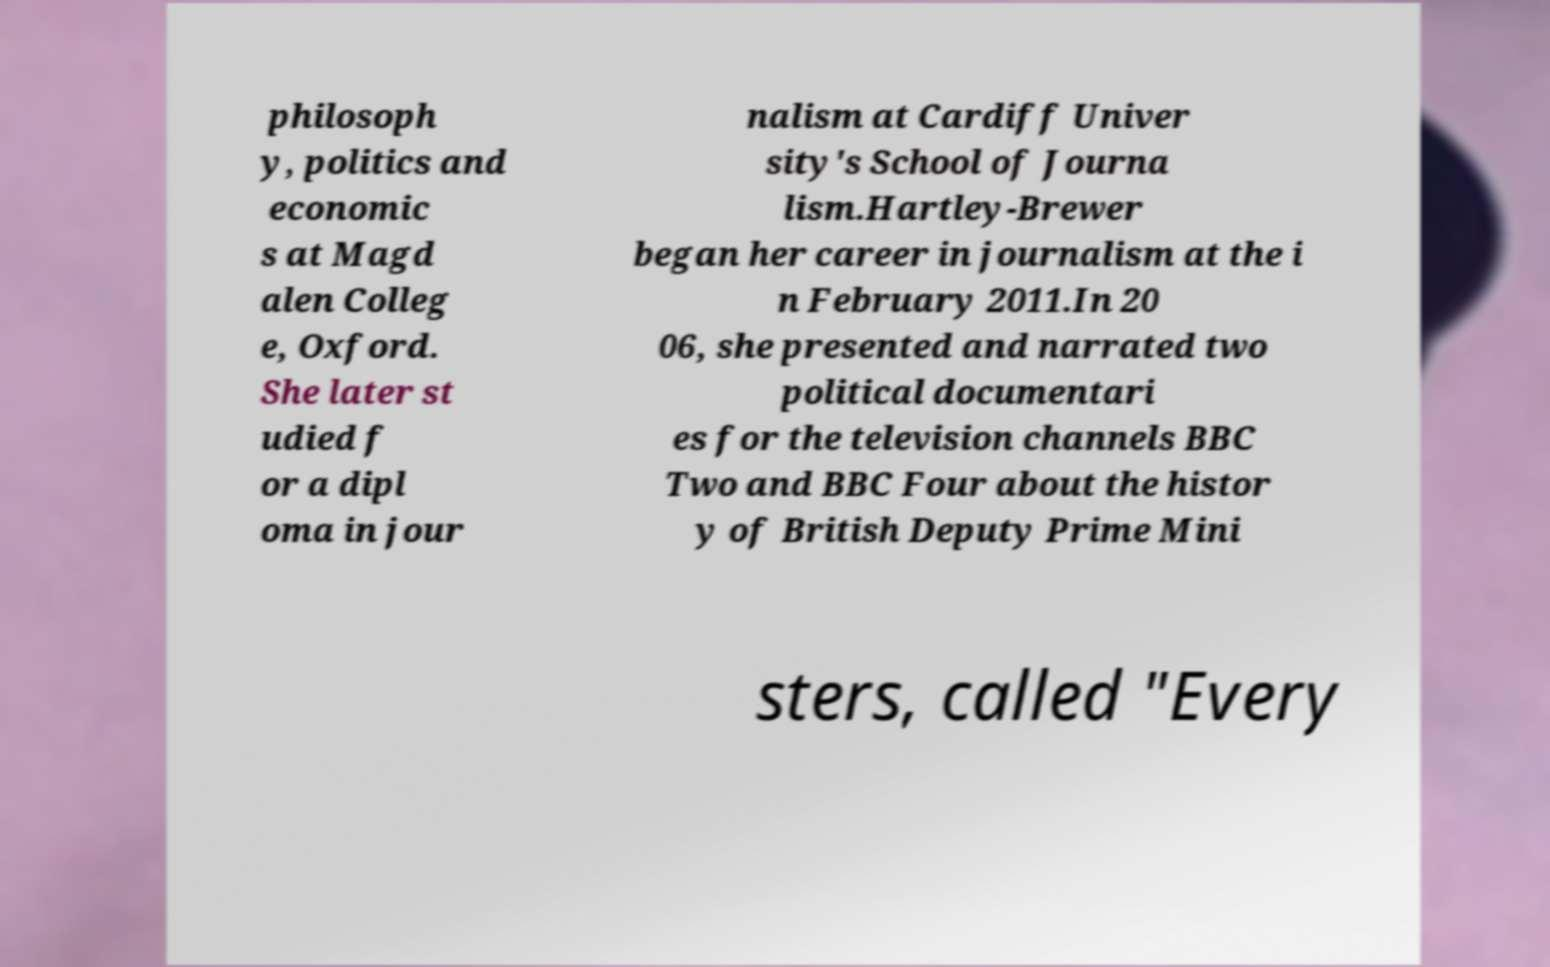I need the written content from this picture converted into text. Can you do that? philosoph y, politics and economic s at Magd alen Colleg e, Oxford. She later st udied f or a dipl oma in jour nalism at Cardiff Univer sity's School of Journa lism.Hartley-Brewer began her career in journalism at the i n February 2011.In 20 06, she presented and narrated two political documentari es for the television channels BBC Two and BBC Four about the histor y of British Deputy Prime Mini sters, called "Every 